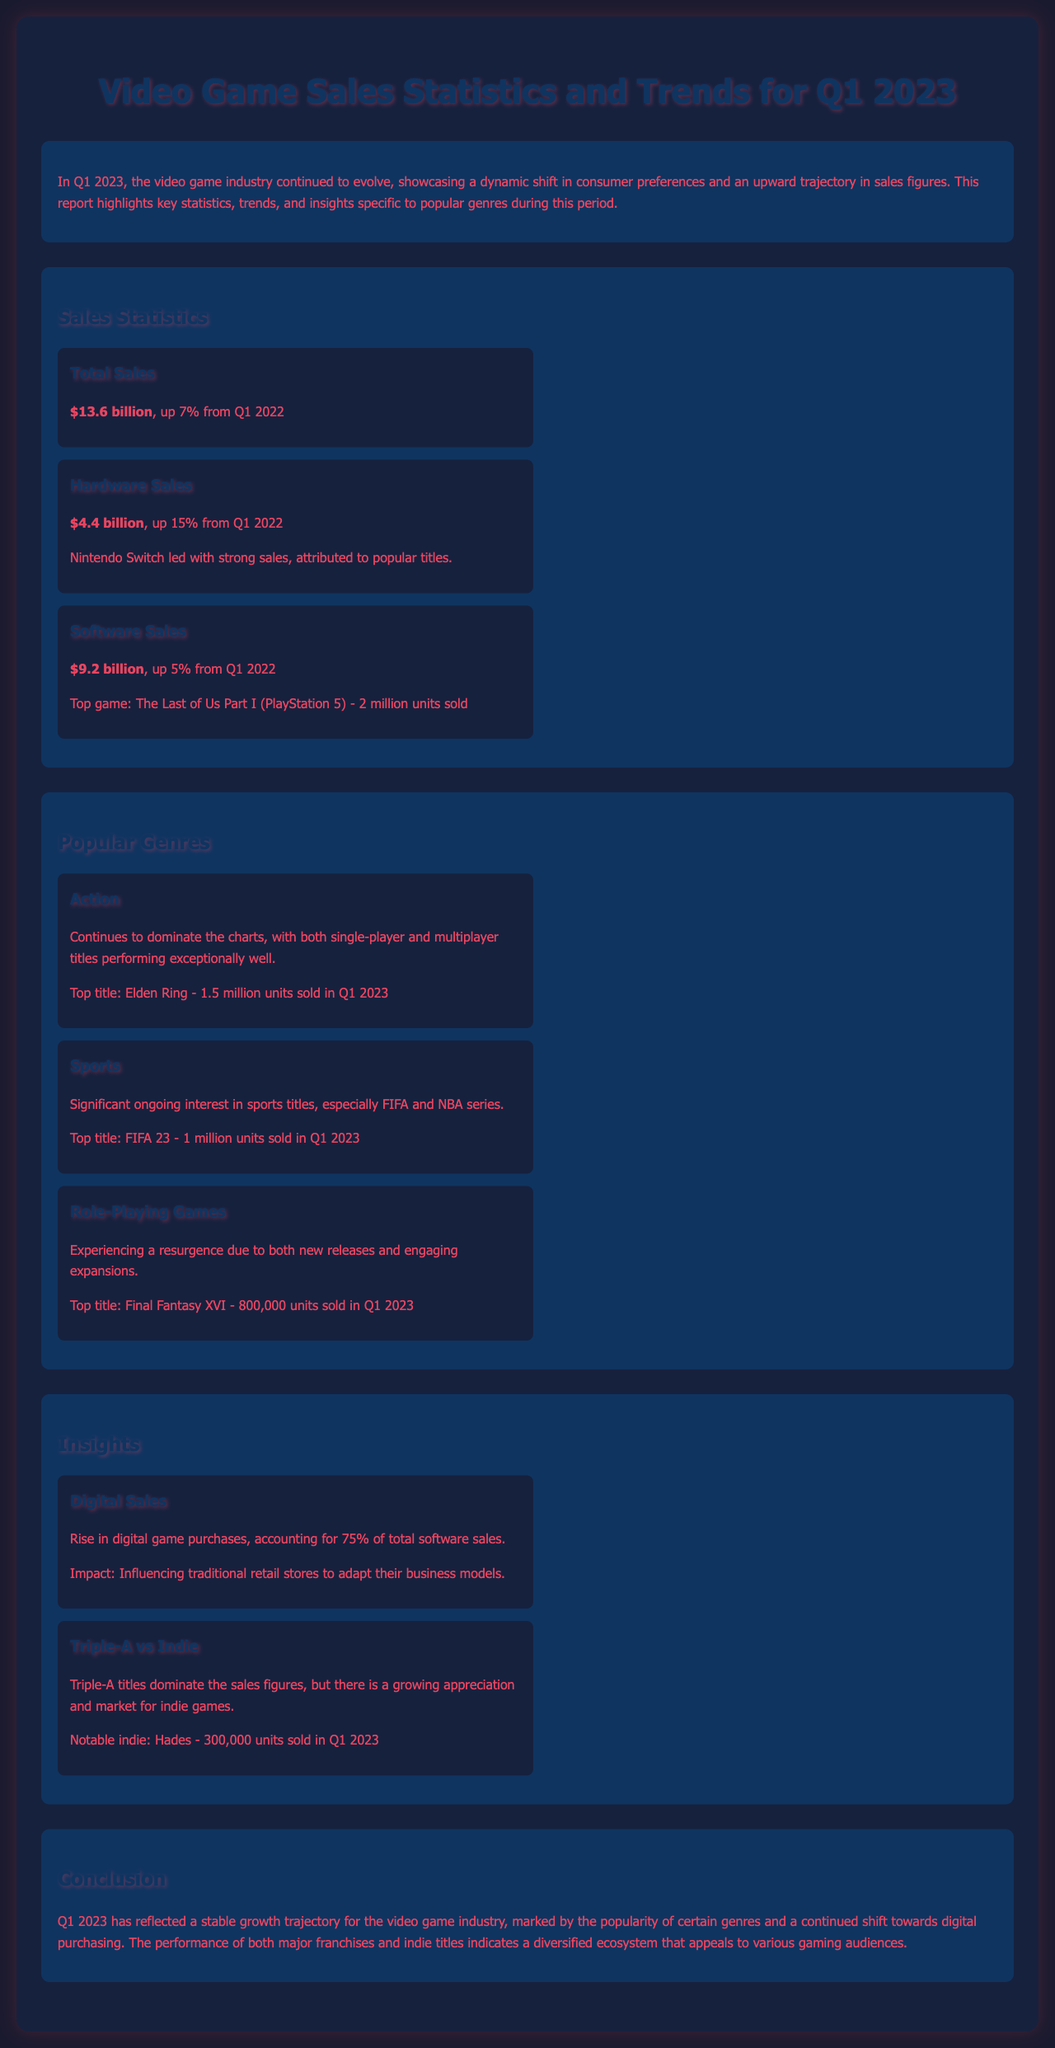What was the total sales for Q1 2023? The total sales figure mentioned is $13.6 billion.
Answer: $13.6 billion Which genre continues to dominate the charts? The document states that the Action genre continues to dominate.
Answer: Action What were the sales figures for hardware? The report highlights that hardware sales reached $4.4 billion.
Answer: $4.4 billion Which title sold the most units in the Role-Playing Games genre? The top title in the RPG genre is Final Fantasy XVI, with 800,000 units sold.
Answer: Final Fantasy XVI What percentage of software sales were digital? The report specifies that digital game purchases accounted for 75% of total software sales.
Answer: 75% How much did the top title Elden Ring sell in Q1 2023? The document states that Elden Ring sold 1.5 million units.
Answer: 1.5 million units What impact did the rise in digital sales have on retail stores? The rise in digital sales influenced traditional retail stores to adapt their business models.
Answer: Adapt their business models What is the notable indie game mentioned in the report? The report mentions the indie game Hades as notable, with 300,000 units sold.
Answer: Hades 